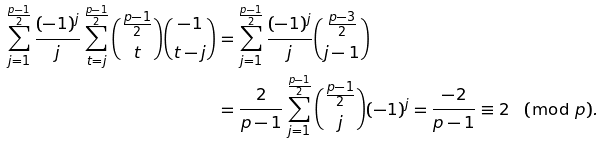Convert formula to latex. <formula><loc_0><loc_0><loc_500><loc_500>\sum _ { j = 1 } ^ { \frac { p - 1 } { 2 } } \frac { ( - 1 ) ^ { j } } { j } \sum _ { t = j } ^ { \frac { p - 1 } { 2 } } \binom { \frac { p - 1 } { 2 } } { t } \binom { - 1 } { t - j } & = \sum _ { j = 1 } ^ { \frac { p - 1 } { 2 } } \frac { ( - 1 ) ^ { j } } { j } \binom { \frac { p - 3 } { 2 } } { j - 1 } \\ & = \frac { 2 } { p - 1 } \sum _ { j = 1 } ^ { \frac { p - 1 } { 2 } } \binom { \frac { p - 1 } { 2 } } { j } ( - 1 ) ^ { j } = \frac { - 2 } { p - 1 } \equiv 2 \pmod { p } .</formula> 